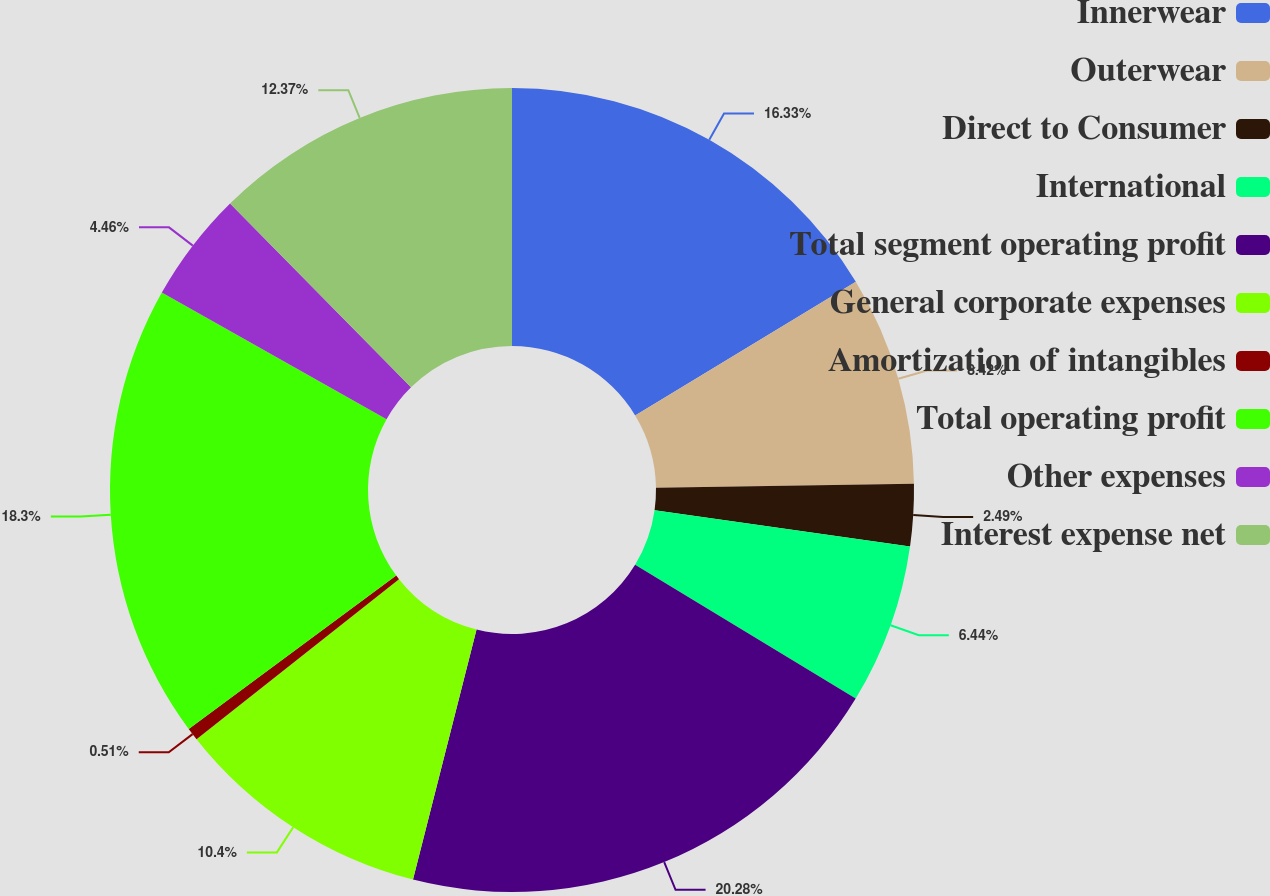<chart> <loc_0><loc_0><loc_500><loc_500><pie_chart><fcel>Innerwear<fcel>Outerwear<fcel>Direct to Consumer<fcel>International<fcel>Total segment operating profit<fcel>General corporate expenses<fcel>Amortization of intangibles<fcel>Total operating profit<fcel>Other expenses<fcel>Interest expense net<nl><fcel>16.33%<fcel>8.42%<fcel>2.49%<fcel>6.44%<fcel>20.28%<fcel>10.4%<fcel>0.51%<fcel>18.3%<fcel>4.46%<fcel>12.37%<nl></chart> 